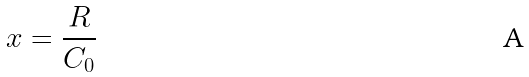<formula> <loc_0><loc_0><loc_500><loc_500>x = \frac { R } { C _ { 0 } }</formula> 